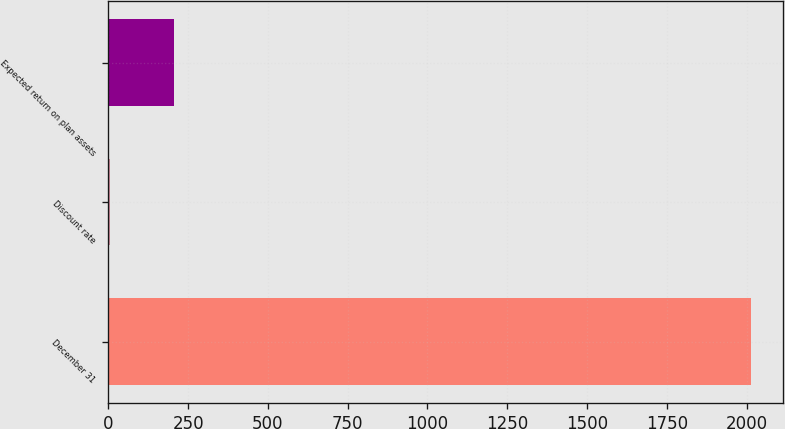Convert chart to OTSL. <chart><loc_0><loc_0><loc_500><loc_500><bar_chart><fcel>December 31<fcel>Discount rate<fcel>Expected return on plan assets<nl><fcel>2015<fcel>4.7<fcel>205.73<nl></chart> 